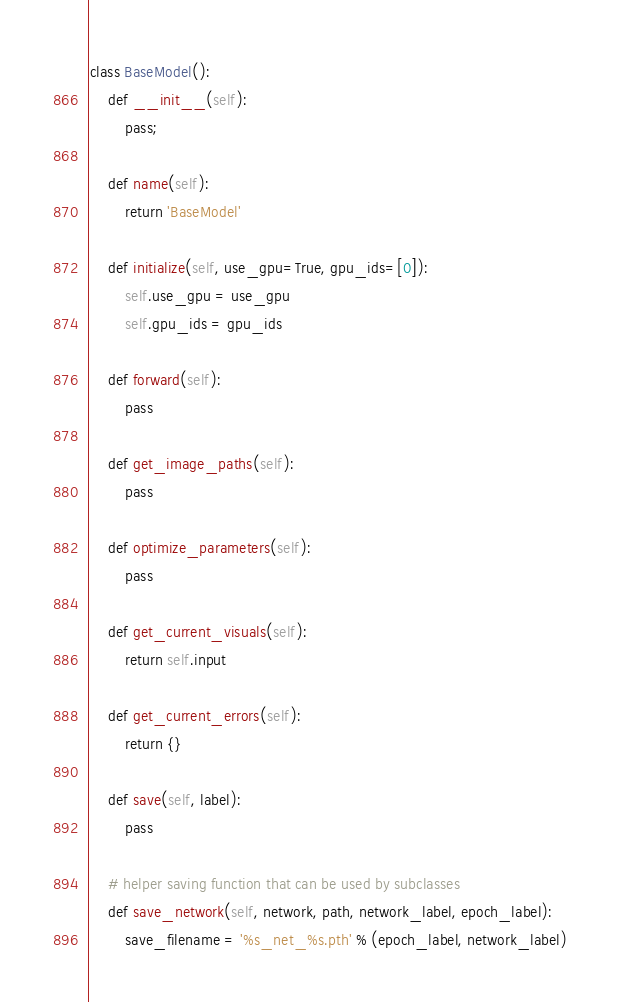Convert code to text. <code><loc_0><loc_0><loc_500><loc_500><_Python_>class BaseModel():
    def __init__(self):
        pass;
        
    def name(self):
        return 'BaseModel'

    def initialize(self, use_gpu=True, gpu_ids=[0]):
        self.use_gpu = use_gpu
        self.gpu_ids = gpu_ids

    def forward(self):
        pass

    def get_image_paths(self):
        pass

    def optimize_parameters(self):
        pass

    def get_current_visuals(self):
        return self.input

    def get_current_errors(self):
        return {}

    def save(self, label):
        pass

    # helper saving function that can be used by subclasses
    def save_network(self, network, path, network_label, epoch_label):
        save_filename = '%s_net_%s.pth' % (epoch_label, network_label)</code> 